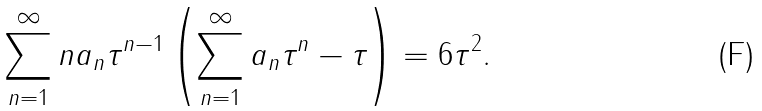Convert formula to latex. <formula><loc_0><loc_0><loc_500><loc_500>\sum _ { n = 1 } ^ { \infty } n a _ { n } \tau ^ { n - 1 } \left ( \sum _ { n = 1 } ^ { \infty } a _ { n } \tau ^ { n } - \tau \right ) = 6 \tau ^ { 2 } .</formula> 